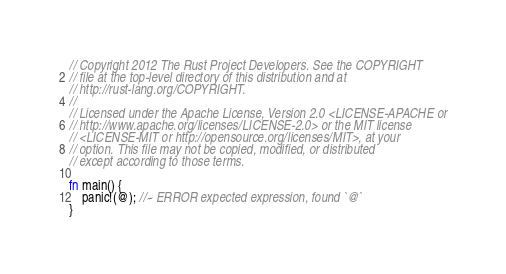<code> <loc_0><loc_0><loc_500><loc_500><_Rust_>// Copyright 2012 The Rust Project Developers. See the COPYRIGHT
// file at the top-level directory of this distribution and at
// http://rust-lang.org/COPYRIGHT.
//
// Licensed under the Apache License, Version 2.0 <LICENSE-APACHE or
// http://www.apache.org/licenses/LICENSE-2.0> or the MIT license
// <LICENSE-MIT or http://opensource.org/licenses/MIT>, at your
// option. This file may not be copied, modified, or distributed
// except according to those terms.

fn main() {
    panic!(@); //~ ERROR expected expression, found `@`
}
</code> 